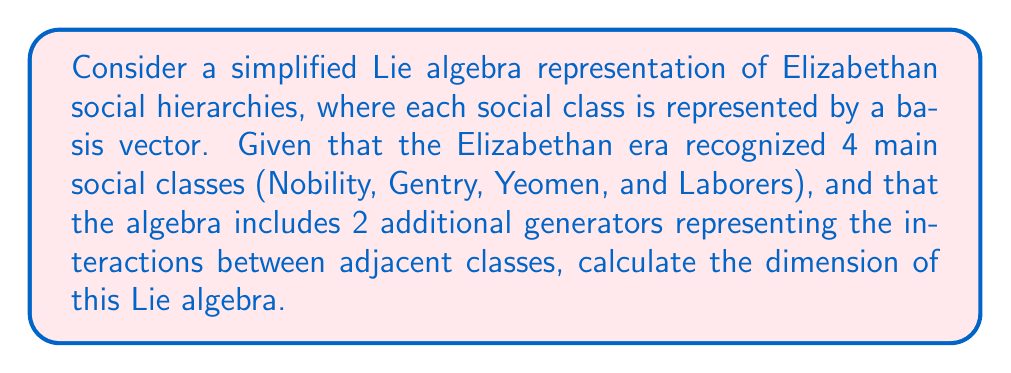Help me with this question. To solve this problem, we need to understand the structure of the proposed Lie algebra:

1. First, we have 4 basis vectors representing the main social classes:
   $e_1$ (Nobility), $e_2$ (Gentry), $e_3$ (Yeomen), and $e_4$ (Laborers)

2. We also have 2 additional generators representing interactions between adjacent classes:
   $f_1$ (interaction between Nobility and Gentry)
   $f_2$ (interaction between Gentry and Yeomen)
   $f_3$ (interaction between Yeomen and Laborers)

The dimension of a Lie algebra is equal to the number of linearly independent basis elements. In this case, we have:

- 4 basis vectors representing social classes: $e_1, e_2, e_3, e_4$
- 3 generators representing interactions: $f_1, f_2, f_3$

To calculate the dimension, we simply sum up the number of these linearly independent elements:

$$\text{dim}(L) = \text{number of class vectors} + \text{number of interaction generators}$$
$$\text{dim}(L) = 4 + 3 = 7$$

Therefore, the dimension of this Lie algebra representing Elizabethan social hierarchies is 7.
Answer: The dimension of the Lie algebra is 7. 